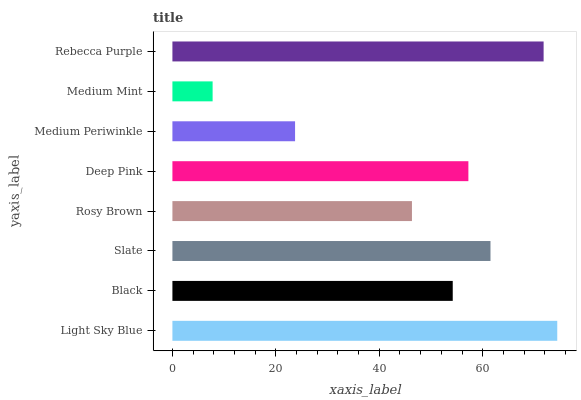Is Medium Mint the minimum?
Answer yes or no. Yes. Is Light Sky Blue the maximum?
Answer yes or no. Yes. Is Black the minimum?
Answer yes or no. No. Is Black the maximum?
Answer yes or no. No. Is Light Sky Blue greater than Black?
Answer yes or no. Yes. Is Black less than Light Sky Blue?
Answer yes or no. Yes. Is Black greater than Light Sky Blue?
Answer yes or no. No. Is Light Sky Blue less than Black?
Answer yes or no. No. Is Deep Pink the high median?
Answer yes or no. Yes. Is Black the low median?
Answer yes or no. Yes. Is Medium Mint the high median?
Answer yes or no. No. Is Slate the low median?
Answer yes or no. No. 